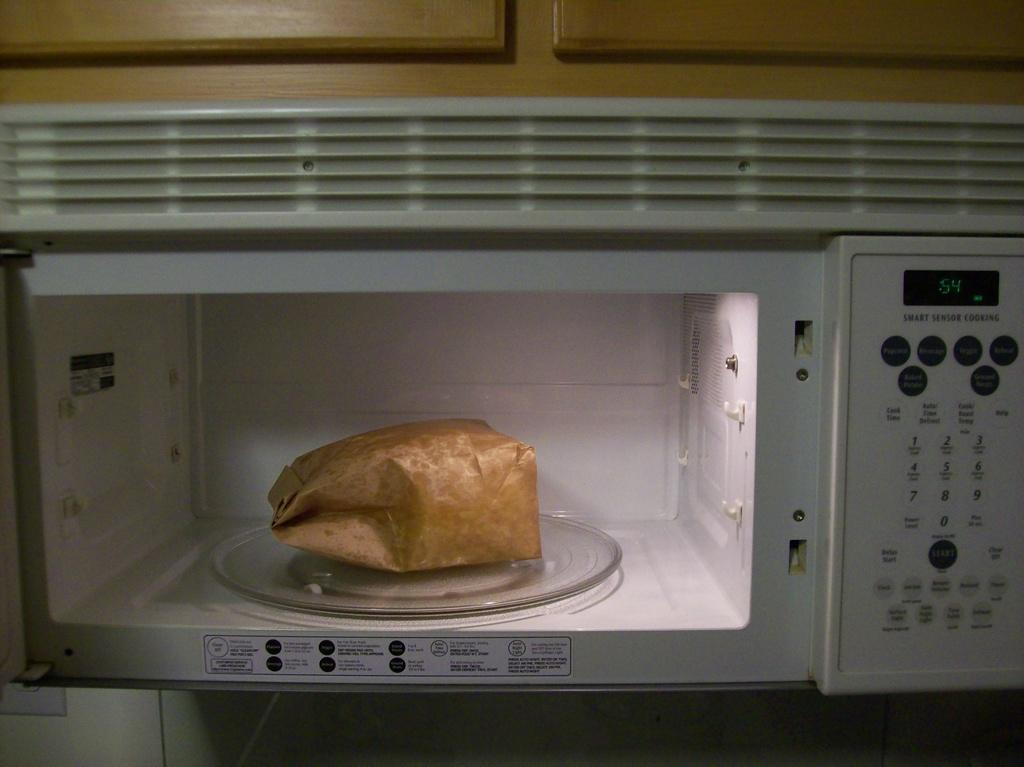What object is inside the microwave in the image? There is a paper bag in the image, and it is inside a microwave. What type of material is used for the cupboards in the image? The cupboards in the image are made of wood. What degree does the governor have in the image? There is no governor or degree mentioned or depicted in the image. 